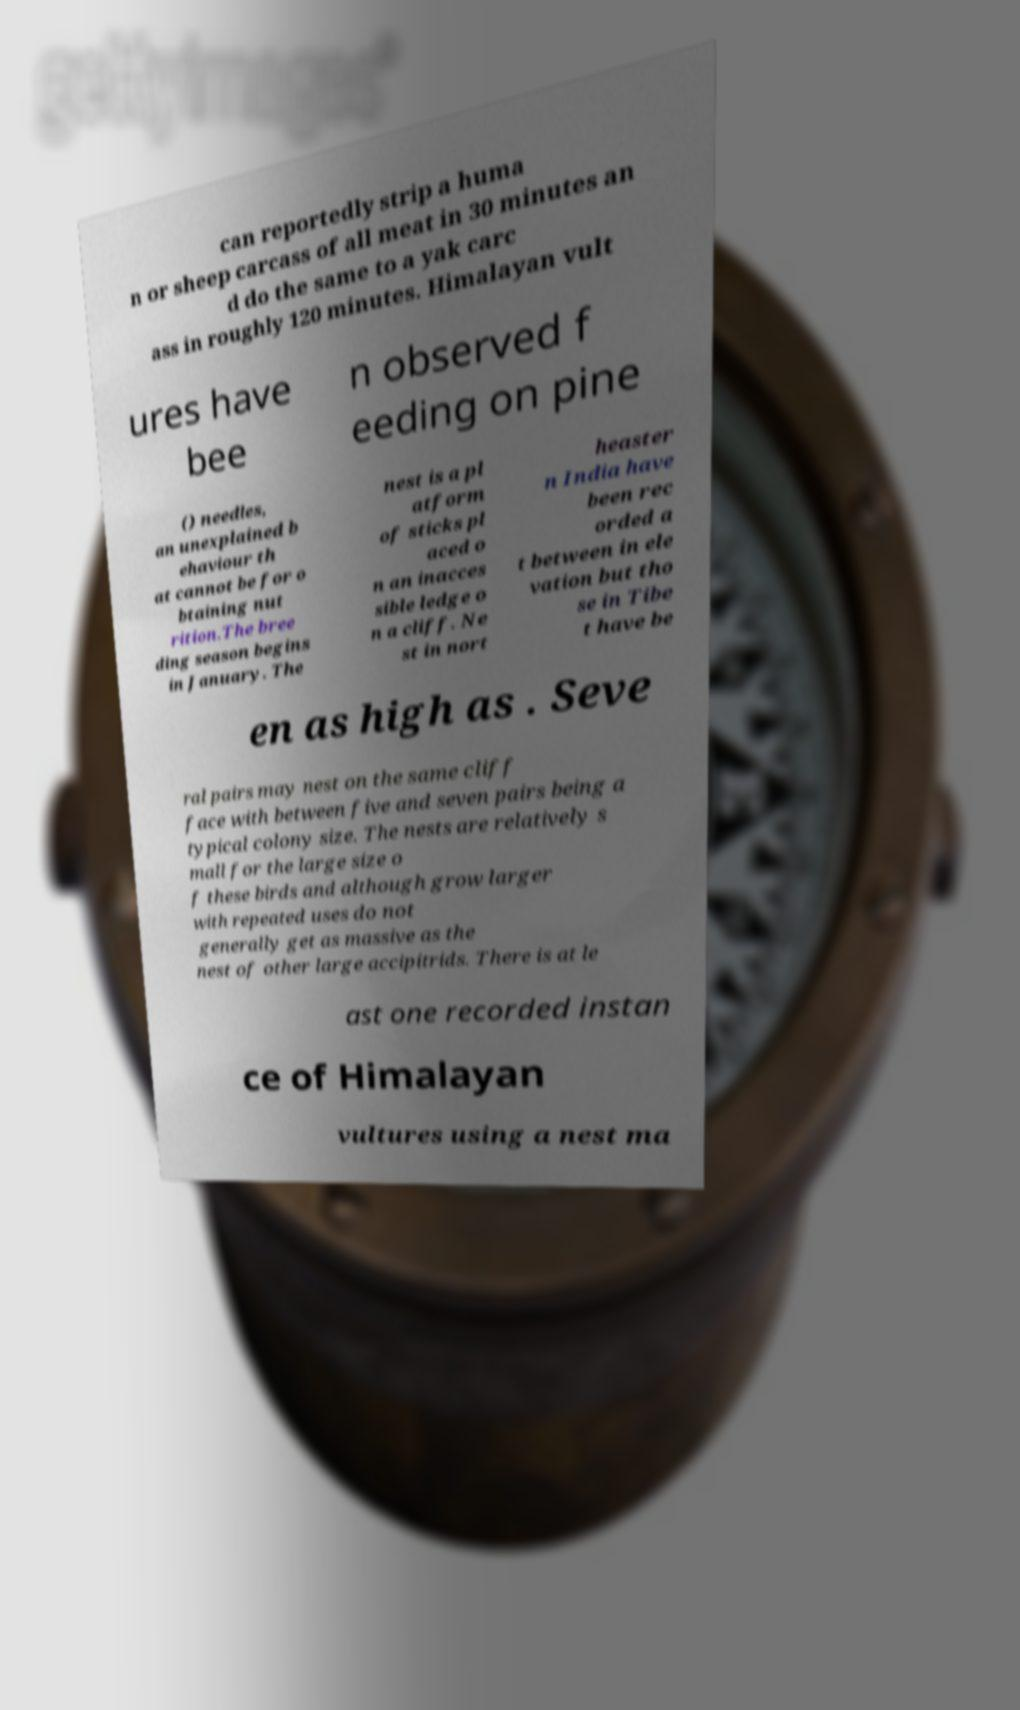For documentation purposes, I need the text within this image transcribed. Could you provide that? can reportedly strip a huma n or sheep carcass of all meat in 30 minutes an d do the same to a yak carc ass in roughly 120 minutes. Himalayan vult ures have bee n observed f eeding on pine () needles, an unexplained b ehaviour th at cannot be for o btaining nut rition.The bree ding season begins in January. The nest is a pl atform of sticks pl aced o n an inacces sible ledge o n a cliff. Ne st in nort heaster n India have been rec orded a t between in ele vation but tho se in Tibe t have be en as high as . Seve ral pairs may nest on the same cliff face with between five and seven pairs being a typical colony size. The nests are relatively s mall for the large size o f these birds and although grow larger with repeated uses do not generally get as massive as the nest of other large accipitrids. There is at le ast one recorded instan ce of Himalayan vultures using a nest ma 